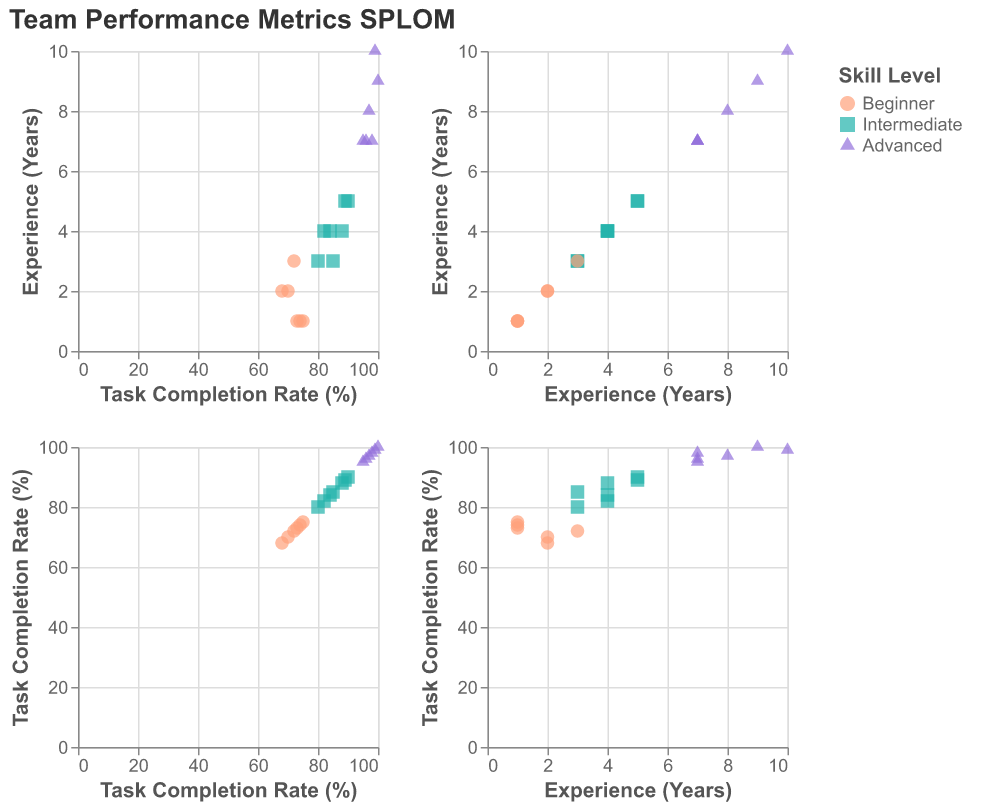What does the title of the figure indicate? The title is displayed at the top of the figure and reads "Team Performance Metrics SPLOM," indicating that the figure is a Scatter Plot Matrix related to team performance metrics.
Answer: Team Performance Metrics SPLOM What are the three skill levels represented in the scatter plots? The legend on the right side of the figure indicates that the three skill levels are Beginner, Intermediate, and Advanced, each represented by different colors and shapes.
Answer: Beginner, Intermediate, Advanced How many data points are there for each skill level? By counting the data points in the scatter plots, we find that Beginner has 5 data points, Intermediate has 6 data points, and Advanced has 6 data points.
Answer: Beginner: 5, Intermediate: 6, Advanced: 6 Which skill level has the highest task completion rate, and what is that rate? By checking the scatter plots, we see that the Advanced skill level has the highest task completion rate, reaching 100%.
Answer: Advanced: 100% What is the range of experience years for Intermediate skill level? By observing the scatter plots, we see that Intermediate skill level ranges from 3 to 5 years of experience.
Answer: 3 to 5 years Are there any data points where Beginner skill level has more than 2 years of experience? By looking at the scatter plots for Beginner skill level, we find one data point with 3 years of experience.
Answer: Yes Compare the task completion rates for Intermediate skill level with 5 years and Advanced skill level with 7 years of experience. The scatter plots show that the task completion rate for Intermediate with 5 years is 89%, while for Advanced with 7 years, it is shown as either 95%, 96%, or 98%. Comparatively, Advanced has a higher rate.
Answer: Advanced (7 years) > Intermediate (5 years) What can be inferred about the relationship between experience and task completion rate for the Advanced skill level? Observing the scatter plots, we see that as experience increases, the task completion rate increases for the Advanced skill level, indicating a positive correlation.
Answer: Positive correlation What is the highest task completion rate for Beginners? By examining the scatter plots, we find that the highest task completion rate for Beginners is 75%.
Answer: 75% Which skill level generally has the lowest task completion rate, and why might that be? Observing the scatter plots, Beginners generally have the lowest task completion rates, which might be due to less experience and skill proficiency.
Answer: Beginner 